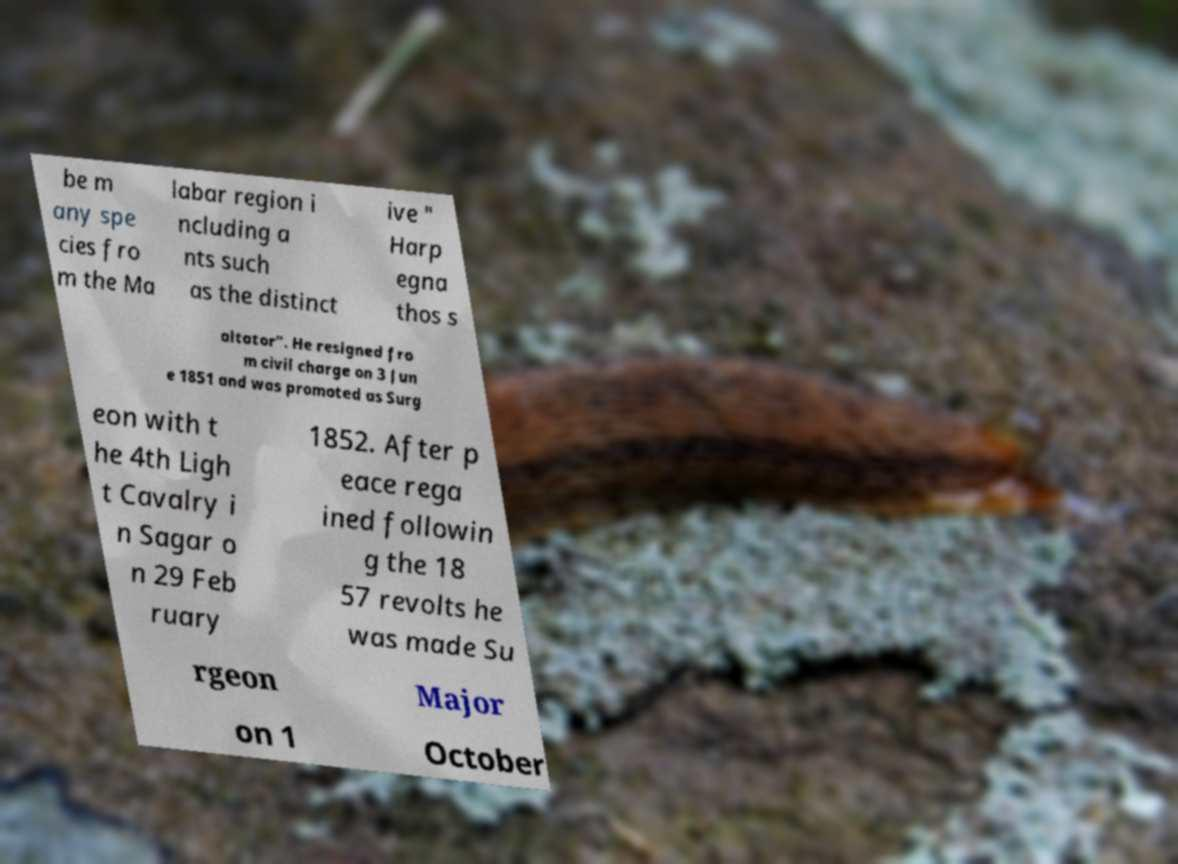Please identify and transcribe the text found in this image. be m any spe cies fro m the Ma labar region i ncluding a nts such as the distinct ive " Harp egna thos s altator". He resigned fro m civil charge on 3 Jun e 1851 and was promoted as Surg eon with t he 4th Ligh t Cavalry i n Sagar o n 29 Feb ruary 1852. After p eace rega ined followin g the 18 57 revolts he was made Su rgeon Major on 1 October 